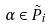<formula> <loc_0><loc_0><loc_500><loc_500>\alpha \in \tilde { P } _ { i }</formula> 